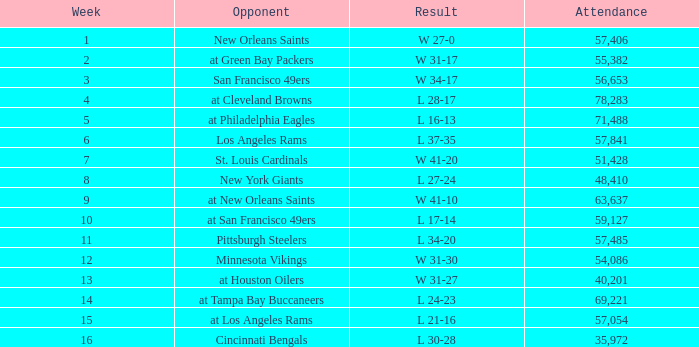What was the highest number of attendance in a week before 8 and game on October 25, 1981? None. 